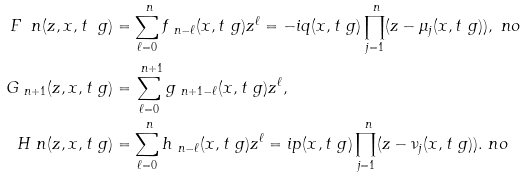<formula> <loc_0><loc_0><loc_500><loc_500>F _ { \ } n ( z , x , t _ { \ } g ) & = \sum _ { \ell = 0 } ^ { \ n } f _ { \ n - \ell } ( x , t _ { \ } g ) z ^ { \ell } = - i q ( x , t _ { \ } g ) \prod _ { j = 1 } ^ { \ n } ( z - \mu _ { j } ( x , t _ { \ } g ) ) , \ n o \\ G _ { \ n + 1 } ( z , x , t _ { \ } g ) & = \sum _ { \ell = 0 } ^ { \ n + 1 } g _ { \ n + 1 - \ell } ( x , t _ { \ } g ) z ^ { \ell } , \\ H _ { \ } n ( z , x , t _ { \ } g ) & = \sum _ { \ell = 0 } ^ { \ n } h _ { \ n - \ell } ( x , t _ { \ } g ) z ^ { \ell } = i p ( x , t _ { \ } g ) \prod _ { j = 1 } ^ { \ n } ( z - \nu _ { j } ( x , t _ { \ } g ) ) . \ n o</formula> 